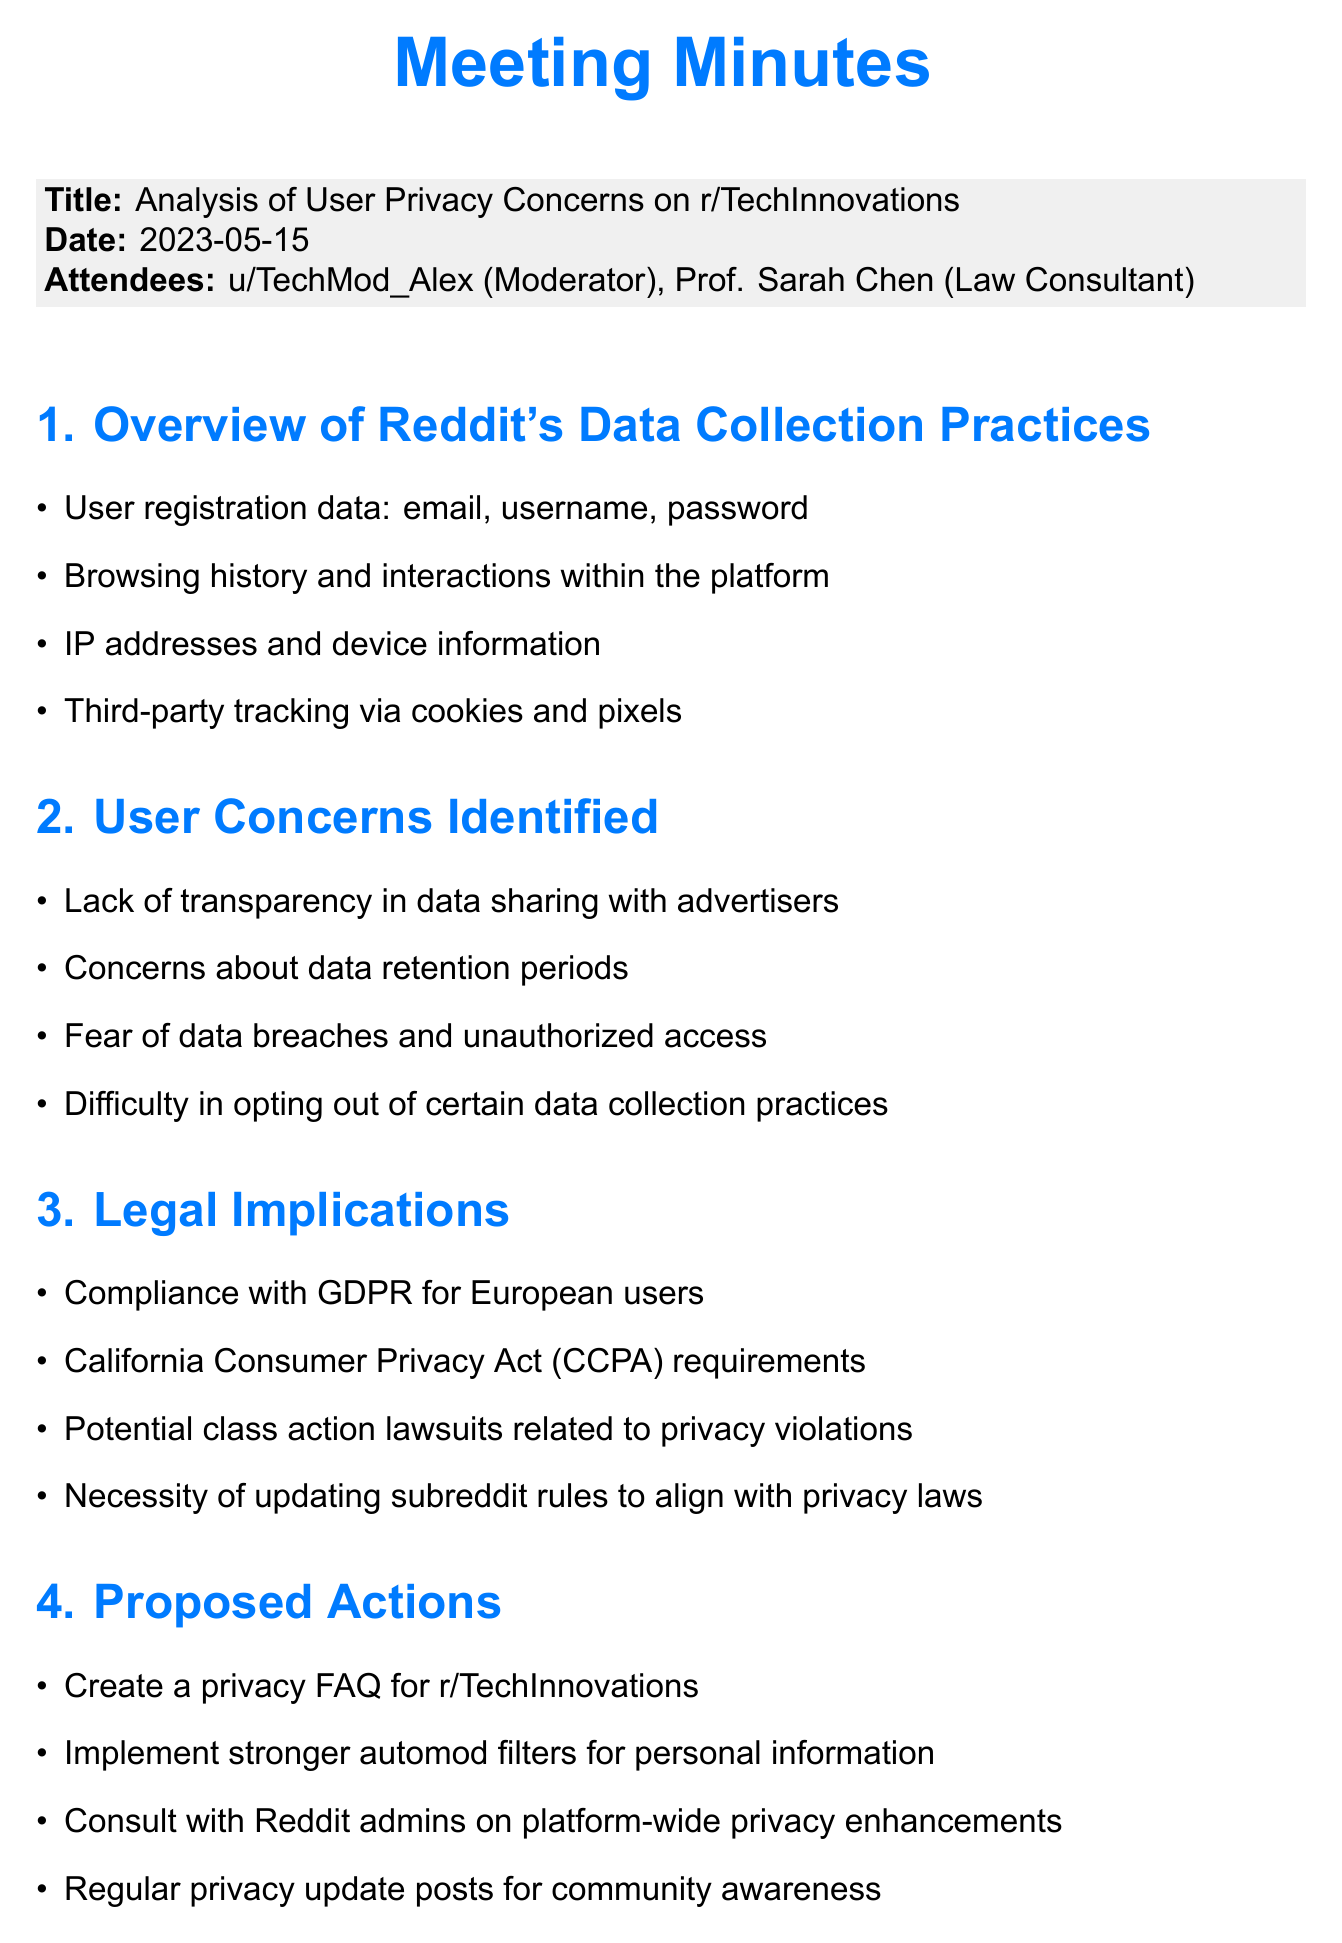What is the date of the meeting? The date is mentioned in the header section of the document.
Answer: 2023-05-15 Who attended the meeting as a law consultant? The attendees section lists the participants of the meeting.
Answer: Prof. Sarah Chen What is one concern identified by users regarding data collection? The document lists user concerns under a specific agenda item.
Answer: Lack of transparency in data sharing with advertisers What are the proposed actions for addressing privacy concerns? The document includes a section on proposed actions with specific suggestions.
Answer: Create a privacy FAQ for r/TechInnovations What legislation must Reddit comply with for European users? Legal implications section mentions necessary compliance related to user data.
Answer: GDPR How many attendees were present at the meeting? The attendees section explicitly states the number of participants.
Answer: 2 What is one item listed under the next steps? The next steps section outlines plans following the meeting.
Answer: Schedule follow-up meeting with Reddit's legal team Which privacy law is relevant to California users? The legal implications section specifies laws applicable to certain users.
Answer: CCPA 